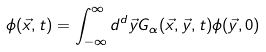<formula> <loc_0><loc_0><loc_500><loc_500>\phi ( \vec { x } , t ) = \int _ { - \infty } ^ { \infty } d ^ { d } \vec { y } G _ { \alpha } ( \vec { x } , \vec { y } , t ) \phi ( \vec { y } , 0 )</formula> 